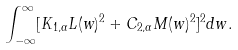Convert formula to latex. <formula><loc_0><loc_0><loc_500><loc_500>\int _ { - \infty } ^ { \infty } [ K _ { 1 , \alpha } L ( w ) ^ { 2 } + C _ { 2 , \alpha } M ( w ) ^ { 2 } ] ^ { 2 } d w .</formula> 